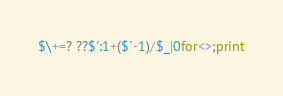Convert code to text. <code><loc_0><loc_0><loc_500><loc_500><_Perl_>$\+=? ??$':1+($`-1)/$_|0for<>;print</code> 